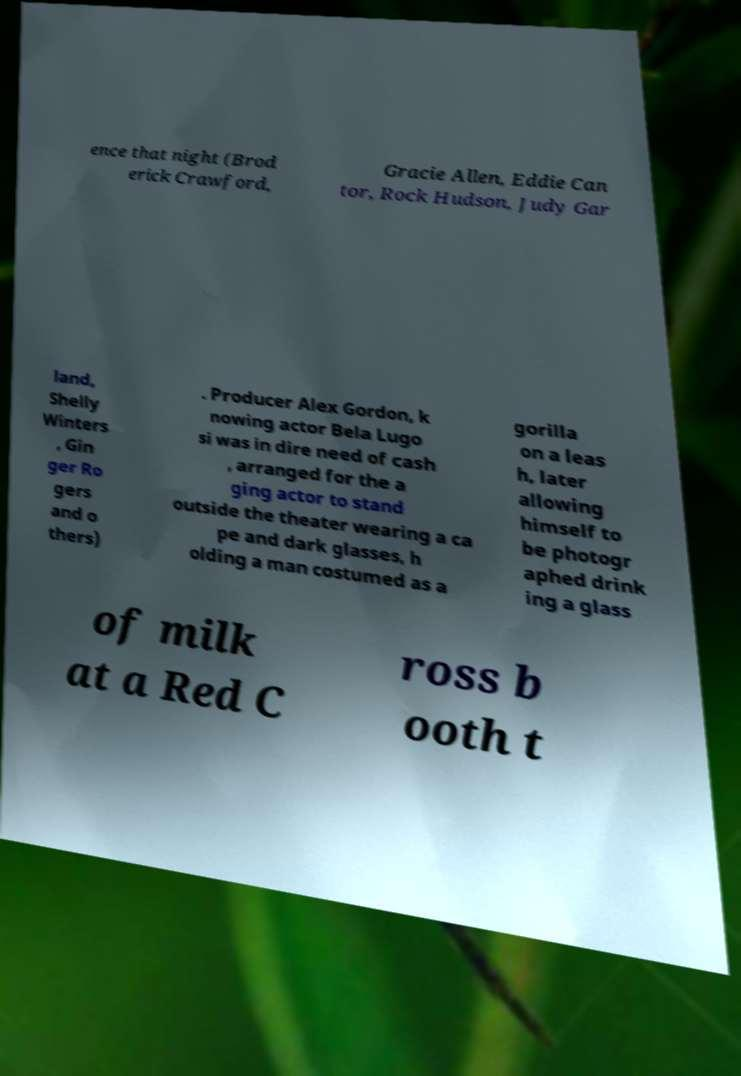There's text embedded in this image that I need extracted. Can you transcribe it verbatim? ence that night (Brod erick Crawford, Gracie Allen, Eddie Can tor, Rock Hudson, Judy Gar land, Shelly Winters , Gin ger Ro gers and o thers) . Producer Alex Gordon, k nowing actor Bela Lugo si was in dire need of cash , arranged for the a ging actor to stand outside the theater wearing a ca pe and dark glasses, h olding a man costumed as a gorilla on a leas h, later allowing himself to be photogr aphed drink ing a glass of milk at a Red C ross b ooth t 